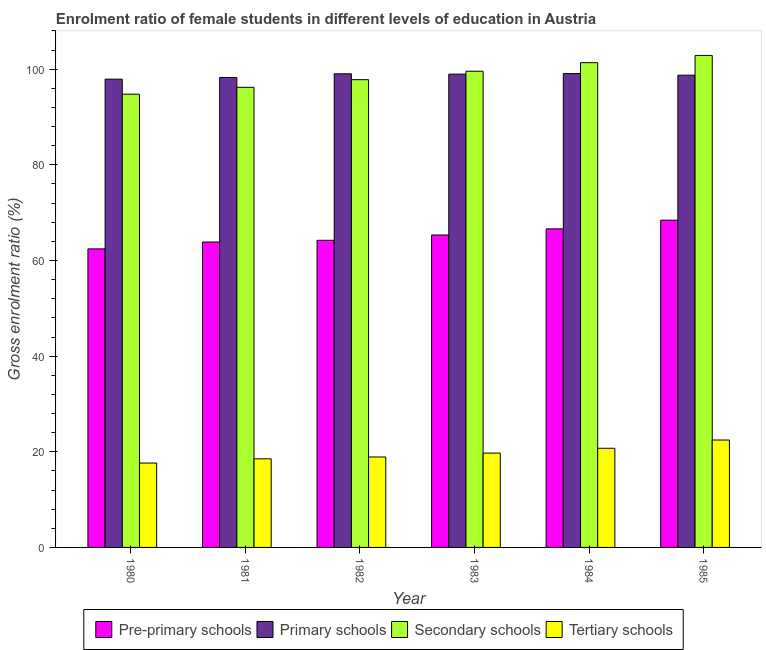How many different coloured bars are there?
Provide a short and direct response. 4. Are the number of bars on each tick of the X-axis equal?
Provide a succinct answer. Yes. How many bars are there on the 1st tick from the right?
Provide a short and direct response. 4. What is the label of the 6th group of bars from the left?
Keep it short and to the point. 1985. In how many cases, is the number of bars for a given year not equal to the number of legend labels?
Offer a very short reply. 0. What is the gross enrolment ratio(male) in tertiary schools in 1981?
Provide a short and direct response. 18.53. Across all years, what is the maximum gross enrolment ratio(male) in pre-primary schools?
Your answer should be compact. 68.43. Across all years, what is the minimum gross enrolment ratio(male) in tertiary schools?
Provide a succinct answer. 17.65. What is the total gross enrolment ratio(male) in pre-primary schools in the graph?
Your answer should be compact. 390.89. What is the difference between the gross enrolment ratio(male) in tertiary schools in 1982 and that in 1983?
Your answer should be compact. -0.82. What is the difference between the gross enrolment ratio(male) in secondary schools in 1983 and the gross enrolment ratio(male) in primary schools in 1984?
Your response must be concise. -1.79. What is the average gross enrolment ratio(male) in pre-primary schools per year?
Provide a short and direct response. 65.15. What is the ratio of the gross enrolment ratio(male) in tertiary schools in 1980 to that in 1985?
Offer a very short reply. 0.79. What is the difference between the highest and the second highest gross enrolment ratio(male) in primary schools?
Your answer should be very brief. 0.05. What is the difference between the highest and the lowest gross enrolment ratio(male) in tertiary schools?
Your answer should be very brief. 4.81. Is the sum of the gross enrolment ratio(male) in pre-primary schools in 1980 and 1985 greater than the maximum gross enrolment ratio(male) in secondary schools across all years?
Your response must be concise. Yes. Is it the case that in every year, the sum of the gross enrolment ratio(male) in tertiary schools and gross enrolment ratio(male) in secondary schools is greater than the sum of gross enrolment ratio(male) in pre-primary schools and gross enrolment ratio(male) in primary schools?
Offer a very short reply. No. What does the 3rd bar from the left in 1981 represents?
Keep it short and to the point. Secondary schools. What does the 2nd bar from the right in 1981 represents?
Your answer should be compact. Secondary schools. Is it the case that in every year, the sum of the gross enrolment ratio(male) in pre-primary schools and gross enrolment ratio(male) in primary schools is greater than the gross enrolment ratio(male) in secondary schools?
Keep it short and to the point. Yes. Are all the bars in the graph horizontal?
Provide a short and direct response. No. How many years are there in the graph?
Make the answer very short. 6. What is the difference between two consecutive major ticks on the Y-axis?
Keep it short and to the point. 20. Does the graph contain any zero values?
Ensure brevity in your answer.  No. Does the graph contain grids?
Keep it short and to the point. No. Where does the legend appear in the graph?
Your answer should be compact. Bottom center. How are the legend labels stacked?
Make the answer very short. Horizontal. What is the title of the graph?
Provide a short and direct response. Enrolment ratio of female students in different levels of education in Austria. What is the label or title of the X-axis?
Your response must be concise. Year. What is the Gross enrolment ratio (%) of Pre-primary schools in 1980?
Your answer should be very brief. 62.43. What is the Gross enrolment ratio (%) of Primary schools in 1980?
Make the answer very short. 97.92. What is the Gross enrolment ratio (%) in Secondary schools in 1980?
Keep it short and to the point. 94.78. What is the Gross enrolment ratio (%) of Tertiary schools in 1980?
Give a very brief answer. 17.65. What is the Gross enrolment ratio (%) in Pre-primary schools in 1981?
Offer a terse response. 63.86. What is the Gross enrolment ratio (%) in Primary schools in 1981?
Make the answer very short. 98.27. What is the Gross enrolment ratio (%) of Secondary schools in 1981?
Your response must be concise. 96.21. What is the Gross enrolment ratio (%) in Tertiary schools in 1981?
Your answer should be very brief. 18.53. What is the Gross enrolment ratio (%) in Pre-primary schools in 1982?
Your answer should be very brief. 64.22. What is the Gross enrolment ratio (%) of Primary schools in 1982?
Provide a short and direct response. 99.04. What is the Gross enrolment ratio (%) of Secondary schools in 1982?
Make the answer very short. 97.81. What is the Gross enrolment ratio (%) of Tertiary schools in 1982?
Your response must be concise. 18.91. What is the Gross enrolment ratio (%) in Pre-primary schools in 1983?
Ensure brevity in your answer.  65.33. What is the Gross enrolment ratio (%) of Primary schools in 1983?
Make the answer very short. 98.97. What is the Gross enrolment ratio (%) in Secondary schools in 1983?
Give a very brief answer. 99.58. What is the Gross enrolment ratio (%) in Tertiary schools in 1983?
Provide a short and direct response. 19.73. What is the Gross enrolment ratio (%) in Pre-primary schools in 1984?
Your response must be concise. 66.61. What is the Gross enrolment ratio (%) in Primary schools in 1984?
Make the answer very short. 99.09. What is the Gross enrolment ratio (%) in Secondary schools in 1984?
Provide a succinct answer. 101.37. What is the Gross enrolment ratio (%) in Tertiary schools in 1984?
Your answer should be very brief. 20.73. What is the Gross enrolment ratio (%) of Pre-primary schools in 1985?
Offer a terse response. 68.43. What is the Gross enrolment ratio (%) in Primary schools in 1985?
Keep it short and to the point. 98.75. What is the Gross enrolment ratio (%) of Secondary schools in 1985?
Provide a succinct answer. 102.88. What is the Gross enrolment ratio (%) in Tertiary schools in 1985?
Your answer should be very brief. 22.46. Across all years, what is the maximum Gross enrolment ratio (%) in Pre-primary schools?
Your response must be concise. 68.43. Across all years, what is the maximum Gross enrolment ratio (%) in Primary schools?
Provide a short and direct response. 99.09. Across all years, what is the maximum Gross enrolment ratio (%) of Secondary schools?
Keep it short and to the point. 102.88. Across all years, what is the maximum Gross enrolment ratio (%) in Tertiary schools?
Provide a short and direct response. 22.46. Across all years, what is the minimum Gross enrolment ratio (%) of Pre-primary schools?
Ensure brevity in your answer.  62.43. Across all years, what is the minimum Gross enrolment ratio (%) in Primary schools?
Provide a succinct answer. 97.92. Across all years, what is the minimum Gross enrolment ratio (%) in Secondary schools?
Offer a very short reply. 94.78. Across all years, what is the minimum Gross enrolment ratio (%) of Tertiary schools?
Offer a very short reply. 17.65. What is the total Gross enrolment ratio (%) in Pre-primary schools in the graph?
Give a very brief answer. 390.89. What is the total Gross enrolment ratio (%) in Primary schools in the graph?
Your answer should be very brief. 592.04. What is the total Gross enrolment ratio (%) of Secondary schools in the graph?
Offer a very short reply. 592.63. What is the total Gross enrolment ratio (%) in Tertiary schools in the graph?
Make the answer very short. 118. What is the difference between the Gross enrolment ratio (%) in Pre-primary schools in 1980 and that in 1981?
Your answer should be compact. -1.44. What is the difference between the Gross enrolment ratio (%) in Primary schools in 1980 and that in 1981?
Give a very brief answer. -0.35. What is the difference between the Gross enrolment ratio (%) of Secondary schools in 1980 and that in 1981?
Provide a succinct answer. -1.44. What is the difference between the Gross enrolment ratio (%) in Tertiary schools in 1980 and that in 1981?
Ensure brevity in your answer.  -0.88. What is the difference between the Gross enrolment ratio (%) of Pre-primary schools in 1980 and that in 1982?
Provide a short and direct response. -1.79. What is the difference between the Gross enrolment ratio (%) of Primary schools in 1980 and that in 1982?
Your answer should be compact. -1.12. What is the difference between the Gross enrolment ratio (%) in Secondary schools in 1980 and that in 1982?
Provide a succinct answer. -3.04. What is the difference between the Gross enrolment ratio (%) of Tertiary schools in 1980 and that in 1982?
Your answer should be very brief. -1.26. What is the difference between the Gross enrolment ratio (%) in Pre-primary schools in 1980 and that in 1983?
Provide a short and direct response. -2.9. What is the difference between the Gross enrolment ratio (%) in Primary schools in 1980 and that in 1983?
Ensure brevity in your answer.  -1.05. What is the difference between the Gross enrolment ratio (%) in Secondary schools in 1980 and that in 1983?
Give a very brief answer. -4.8. What is the difference between the Gross enrolment ratio (%) of Tertiary schools in 1980 and that in 1983?
Provide a short and direct response. -2.08. What is the difference between the Gross enrolment ratio (%) of Pre-primary schools in 1980 and that in 1984?
Your response must be concise. -4.19. What is the difference between the Gross enrolment ratio (%) of Primary schools in 1980 and that in 1984?
Your answer should be compact. -1.17. What is the difference between the Gross enrolment ratio (%) of Secondary schools in 1980 and that in 1984?
Your answer should be very brief. -6.59. What is the difference between the Gross enrolment ratio (%) of Tertiary schools in 1980 and that in 1984?
Your answer should be very brief. -3.09. What is the difference between the Gross enrolment ratio (%) of Pre-primary schools in 1980 and that in 1985?
Give a very brief answer. -6. What is the difference between the Gross enrolment ratio (%) in Primary schools in 1980 and that in 1985?
Your answer should be compact. -0.83. What is the difference between the Gross enrolment ratio (%) in Secondary schools in 1980 and that in 1985?
Your answer should be very brief. -8.11. What is the difference between the Gross enrolment ratio (%) in Tertiary schools in 1980 and that in 1985?
Your answer should be very brief. -4.81. What is the difference between the Gross enrolment ratio (%) in Pre-primary schools in 1981 and that in 1982?
Provide a succinct answer. -0.36. What is the difference between the Gross enrolment ratio (%) of Primary schools in 1981 and that in 1982?
Provide a short and direct response. -0.77. What is the difference between the Gross enrolment ratio (%) in Secondary schools in 1981 and that in 1982?
Your response must be concise. -1.6. What is the difference between the Gross enrolment ratio (%) of Tertiary schools in 1981 and that in 1982?
Provide a succinct answer. -0.38. What is the difference between the Gross enrolment ratio (%) of Pre-primary schools in 1981 and that in 1983?
Offer a terse response. -1.47. What is the difference between the Gross enrolment ratio (%) of Secondary schools in 1981 and that in 1983?
Ensure brevity in your answer.  -3.37. What is the difference between the Gross enrolment ratio (%) of Tertiary schools in 1981 and that in 1983?
Provide a succinct answer. -1.2. What is the difference between the Gross enrolment ratio (%) in Pre-primary schools in 1981 and that in 1984?
Offer a terse response. -2.75. What is the difference between the Gross enrolment ratio (%) in Primary schools in 1981 and that in 1984?
Ensure brevity in your answer.  -0.82. What is the difference between the Gross enrolment ratio (%) of Secondary schools in 1981 and that in 1984?
Make the answer very short. -5.15. What is the difference between the Gross enrolment ratio (%) of Tertiary schools in 1981 and that in 1984?
Give a very brief answer. -2.21. What is the difference between the Gross enrolment ratio (%) in Pre-primary schools in 1981 and that in 1985?
Give a very brief answer. -4.57. What is the difference between the Gross enrolment ratio (%) of Primary schools in 1981 and that in 1985?
Provide a succinct answer. -0.48. What is the difference between the Gross enrolment ratio (%) of Secondary schools in 1981 and that in 1985?
Make the answer very short. -6.67. What is the difference between the Gross enrolment ratio (%) of Tertiary schools in 1981 and that in 1985?
Offer a terse response. -3.93. What is the difference between the Gross enrolment ratio (%) of Pre-primary schools in 1982 and that in 1983?
Offer a terse response. -1.11. What is the difference between the Gross enrolment ratio (%) of Primary schools in 1982 and that in 1983?
Offer a terse response. 0.07. What is the difference between the Gross enrolment ratio (%) in Secondary schools in 1982 and that in 1983?
Give a very brief answer. -1.76. What is the difference between the Gross enrolment ratio (%) of Tertiary schools in 1982 and that in 1983?
Provide a short and direct response. -0.82. What is the difference between the Gross enrolment ratio (%) of Pre-primary schools in 1982 and that in 1984?
Your response must be concise. -2.39. What is the difference between the Gross enrolment ratio (%) of Primary schools in 1982 and that in 1984?
Your answer should be compact. -0.05. What is the difference between the Gross enrolment ratio (%) in Secondary schools in 1982 and that in 1984?
Give a very brief answer. -3.55. What is the difference between the Gross enrolment ratio (%) of Tertiary schools in 1982 and that in 1984?
Make the answer very short. -1.82. What is the difference between the Gross enrolment ratio (%) in Pre-primary schools in 1982 and that in 1985?
Offer a terse response. -4.21. What is the difference between the Gross enrolment ratio (%) of Primary schools in 1982 and that in 1985?
Offer a very short reply. 0.3. What is the difference between the Gross enrolment ratio (%) of Secondary schools in 1982 and that in 1985?
Ensure brevity in your answer.  -5.07. What is the difference between the Gross enrolment ratio (%) in Tertiary schools in 1982 and that in 1985?
Provide a short and direct response. -3.55. What is the difference between the Gross enrolment ratio (%) of Pre-primary schools in 1983 and that in 1984?
Provide a short and direct response. -1.28. What is the difference between the Gross enrolment ratio (%) of Primary schools in 1983 and that in 1984?
Ensure brevity in your answer.  -0.12. What is the difference between the Gross enrolment ratio (%) in Secondary schools in 1983 and that in 1984?
Provide a short and direct response. -1.79. What is the difference between the Gross enrolment ratio (%) in Tertiary schools in 1983 and that in 1984?
Provide a succinct answer. -1.01. What is the difference between the Gross enrolment ratio (%) in Pre-primary schools in 1983 and that in 1985?
Your answer should be compact. -3.1. What is the difference between the Gross enrolment ratio (%) in Primary schools in 1983 and that in 1985?
Ensure brevity in your answer.  0.22. What is the difference between the Gross enrolment ratio (%) in Secondary schools in 1983 and that in 1985?
Offer a very short reply. -3.3. What is the difference between the Gross enrolment ratio (%) of Tertiary schools in 1983 and that in 1985?
Offer a very short reply. -2.73. What is the difference between the Gross enrolment ratio (%) in Pre-primary schools in 1984 and that in 1985?
Your response must be concise. -1.82. What is the difference between the Gross enrolment ratio (%) in Primary schools in 1984 and that in 1985?
Your answer should be compact. 0.34. What is the difference between the Gross enrolment ratio (%) in Secondary schools in 1984 and that in 1985?
Your answer should be very brief. -1.52. What is the difference between the Gross enrolment ratio (%) of Tertiary schools in 1984 and that in 1985?
Offer a terse response. -1.72. What is the difference between the Gross enrolment ratio (%) of Pre-primary schools in 1980 and the Gross enrolment ratio (%) of Primary schools in 1981?
Provide a succinct answer. -35.84. What is the difference between the Gross enrolment ratio (%) in Pre-primary schools in 1980 and the Gross enrolment ratio (%) in Secondary schools in 1981?
Ensure brevity in your answer.  -33.78. What is the difference between the Gross enrolment ratio (%) in Pre-primary schools in 1980 and the Gross enrolment ratio (%) in Tertiary schools in 1981?
Make the answer very short. 43.9. What is the difference between the Gross enrolment ratio (%) of Primary schools in 1980 and the Gross enrolment ratio (%) of Secondary schools in 1981?
Provide a succinct answer. 1.71. What is the difference between the Gross enrolment ratio (%) of Primary schools in 1980 and the Gross enrolment ratio (%) of Tertiary schools in 1981?
Ensure brevity in your answer.  79.4. What is the difference between the Gross enrolment ratio (%) of Secondary schools in 1980 and the Gross enrolment ratio (%) of Tertiary schools in 1981?
Give a very brief answer. 76.25. What is the difference between the Gross enrolment ratio (%) of Pre-primary schools in 1980 and the Gross enrolment ratio (%) of Primary schools in 1982?
Your response must be concise. -36.61. What is the difference between the Gross enrolment ratio (%) in Pre-primary schools in 1980 and the Gross enrolment ratio (%) in Secondary schools in 1982?
Your answer should be compact. -35.39. What is the difference between the Gross enrolment ratio (%) in Pre-primary schools in 1980 and the Gross enrolment ratio (%) in Tertiary schools in 1982?
Offer a terse response. 43.52. What is the difference between the Gross enrolment ratio (%) in Primary schools in 1980 and the Gross enrolment ratio (%) in Secondary schools in 1982?
Ensure brevity in your answer.  0.11. What is the difference between the Gross enrolment ratio (%) of Primary schools in 1980 and the Gross enrolment ratio (%) of Tertiary schools in 1982?
Your answer should be compact. 79.01. What is the difference between the Gross enrolment ratio (%) of Secondary schools in 1980 and the Gross enrolment ratio (%) of Tertiary schools in 1982?
Make the answer very short. 75.87. What is the difference between the Gross enrolment ratio (%) of Pre-primary schools in 1980 and the Gross enrolment ratio (%) of Primary schools in 1983?
Offer a very short reply. -36.54. What is the difference between the Gross enrolment ratio (%) in Pre-primary schools in 1980 and the Gross enrolment ratio (%) in Secondary schools in 1983?
Provide a succinct answer. -37.15. What is the difference between the Gross enrolment ratio (%) of Pre-primary schools in 1980 and the Gross enrolment ratio (%) of Tertiary schools in 1983?
Offer a terse response. 42.7. What is the difference between the Gross enrolment ratio (%) of Primary schools in 1980 and the Gross enrolment ratio (%) of Secondary schools in 1983?
Your answer should be very brief. -1.66. What is the difference between the Gross enrolment ratio (%) of Primary schools in 1980 and the Gross enrolment ratio (%) of Tertiary schools in 1983?
Your answer should be compact. 78.19. What is the difference between the Gross enrolment ratio (%) in Secondary schools in 1980 and the Gross enrolment ratio (%) in Tertiary schools in 1983?
Ensure brevity in your answer.  75.05. What is the difference between the Gross enrolment ratio (%) in Pre-primary schools in 1980 and the Gross enrolment ratio (%) in Primary schools in 1984?
Ensure brevity in your answer.  -36.66. What is the difference between the Gross enrolment ratio (%) of Pre-primary schools in 1980 and the Gross enrolment ratio (%) of Secondary schools in 1984?
Give a very brief answer. -38.94. What is the difference between the Gross enrolment ratio (%) of Pre-primary schools in 1980 and the Gross enrolment ratio (%) of Tertiary schools in 1984?
Provide a short and direct response. 41.69. What is the difference between the Gross enrolment ratio (%) in Primary schools in 1980 and the Gross enrolment ratio (%) in Secondary schools in 1984?
Provide a short and direct response. -3.45. What is the difference between the Gross enrolment ratio (%) in Primary schools in 1980 and the Gross enrolment ratio (%) in Tertiary schools in 1984?
Offer a terse response. 77.19. What is the difference between the Gross enrolment ratio (%) in Secondary schools in 1980 and the Gross enrolment ratio (%) in Tertiary schools in 1984?
Provide a succinct answer. 74.04. What is the difference between the Gross enrolment ratio (%) of Pre-primary schools in 1980 and the Gross enrolment ratio (%) of Primary schools in 1985?
Offer a very short reply. -36.32. What is the difference between the Gross enrolment ratio (%) in Pre-primary schools in 1980 and the Gross enrolment ratio (%) in Secondary schools in 1985?
Keep it short and to the point. -40.45. What is the difference between the Gross enrolment ratio (%) in Pre-primary schools in 1980 and the Gross enrolment ratio (%) in Tertiary schools in 1985?
Ensure brevity in your answer.  39.97. What is the difference between the Gross enrolment ratio (%) in Primary schools in 1980 and the Gross enrolment ratio (%) in Secondary schools in 1985?
Offer a terse response. -4.96. What is the difference between the Gross enrolment ratio (%) in Primary schools in 1980 and the Gross enrolment ratio (%) in Tertiary schools in 1985?
Your answer should be very brief. 75.46. What is the difference between the Gross enrolment ratio (%) in Secondary schools in 1980 and the Gross enrolment ratio (%) in Tertiary schools in 1985?
Your response must be concise. 72.32. What is the difference between the Gross enrolment ratio (%) of Pre-primary schools in 1981 and the Gross enrolment ratio (%) of Primary schools in 1982?
Your answer should be compact. -35.18. What is the difference between the Gross enrolment ratio (%) in Pre-primary schools in 1981 and the Gross enrolment ratio (%) in Secondary schools in 1982?
Make the answer very short. -33.95. What is the difference between the Gross enrolment ratio (%) of Pre-primary schools in 1981 and the Gross enrolment ratio (%) of Tertiary schools in 1982?
Provide a succinct answer. 44.95. What is the difference between the Gross enrolment ratio (%) in Primary schools in 1981 and the Gross enrolment ratio (%) in Secondary schools in 1982?
Provide a short and direct response. 0.46. What is the difference between the Gross enrolment ratio (%) in Primary schools in 1981 and the Gross enrolment ratio (%) in Tertiary schools in 1982?
Your response must be concise. 79.36. What is the difference between the Gross enrolment ratio (%) of Secondary schools in 1981 and the Gross enrolment ratio (%) of Tertiary schools in 1982?
Your answer should be very brief. 77.3. What is the difference between the Gross enrolment ratio (%) of Pre-primary schools in 1981 and the Gross enrolment ratio (%) of Primary schools in 1983?
Give a very brief answer. -35.11. What is the difference between the Gross enrolment ratio (%) in Pre-primary schools in 1981 and the Gross enrolment ratio (%) in Secondary schools in 1983?
Offer a terse response. -35.71. What is the difference between the Gross enrolment ratio (%) in Pre-primary schools in 1981 and the Gross enrolment ratio (%) in Tertiary schools in 1983?
Keep it short and to the point. 44.14. What is the difference between the Gross enrolment ratio (%) of Primary schools in 1981 and the Gross enrolment ratio (%) of Secondary schools in 1983?
Provide a succinct answer. -1.31. What is the difference between the Gross enrolment ratio (%) of Primary schools in 1981 and the Gross enrolment ratio (%) of Tertiary schools in 1983?
Ensure brevity in your answer.  78.54. What is the difference between the Gross enrolment ratio (%) of Secondary schools in 1981 and the Gross enrolment ratio (%) of Tertiary schools in 1983?
Make the answer very short. 76.49. What is the difference between the Gross enrolment ratio (%) of Pre-primary schools in 1981 and the Gross enrolment ratio (%) of Primary schools in 1984?
Ensure brevity in your answer.  -35.22. What is the difference between the Gross enrolment ratio (%) in Pre-primary schools in 1981 and the Gross enrolment ratio (%) in Secondary schools in 1984?
Your response must be concise. -37.5. What is the difference between the Gross enrolment ratio (%) in Pre-primary schools in 1981 and the Gross enrolment ratio (%) in Tertiary schools in 1984?
Make the answer very short. 43.13. What is the difference between the Gross enrolment ratio (%) of Primary schools in 1981 and the Gross enrolment ratio (%) of Secondary schools in 1984?
Offer a very short reply. -3.1. What is the difference between the Gross enrolment ratio (%) in Primary schools in 1981 and the Gross enrolment ratio (%) in Tertiary schools in 1984?
Make the answer very short. 77.54. What is the difference between the Gross enrolment ratio (%) in Secondary schools in 1981 and the Gross enrolment ratio (%) in Tertiary schools in 1984?
Provide a short and direct response. 75.48. What is the difference between the Gross enrolment ratio (%) of Pre-primary schools in 1981 and the Gross enrolment ratio (%) of Primary schools in 1985?
Make the answer very short. -34.88. What is the difference between the Gross enrolment ratio (%) of Pre-primary schools in 1981 and the Gross enrolment ratio (%) of Secondary schools in 1985?
Offer a very short reply. -39.02. What is the difference between the Gross enrolment ratio (%) in Pre-primary schools in 1981 and the Gross enrolment ratio (%) in Tertiary schools in 1985?
Your response must be concise. 41.41. What is the difference between the Gross enrolment ratio (%) of Primary schools in 1981 and the Gross enrolment ratio (%) of Secondary schools in 1985?
Your answer should be compact. -4.61. What is the difference between the Gross enrolment ratio (%) of Primary schools in 1981 and the Gross enrolment ratio (%) of Tertiary schools in 1985?
Your response must be concise. 75.81. What is the difference between the Gross enrolment ratio (%) of Secondary schools in 1981 and the Gross enrolment ratio (%) of Tertiary schools in 1985?
Your answer should be very brief. 73.76. What is the difference between the Gross enrolment ratio (%) in Pre-primary schools in 1982 and the Gross enrolment ratio (%) in Primary schools in 1983?
Offer a very short reply. -34.75. What is the difference between the Gross enrolment ratio (%) in Pre-primary schools in 1982 and the Gross enrolment ratio (%) in Secondary schools in 1983?
Provide a succinct answer. -35.36. What is the difference between the Gross enrolment ratio (%) of Pre-primary schools in 1982 and the Gross enrolment ratio (%) of Tertiary schools in 1983?
Your response must be concise. 44.5. What is the difference between the Gross enrolment ratio (%) in Primary schools in 1982 and the Gross enrolment ratio (%) in Secondary schools in 1983?
Your response must be concise. -0.54. What is the difference between the Gross enrolment ratio (%) in Primary schools in 1982 and the Gross enrolment ratio (%) in Tertiary schools in 1983?
Your answer should be compact. 79.32. What is the difference between the Gross enrolment ratio (%) in Secondary schools in 1982 and the Gross enrolment ratio (%) in Tertiary schools in 1983?
Ensure brevity in your answer.  78.09. What is the difference between the Gross enrolment ratio (%) of Pre-primary schools in 1982 and the Gross enrolment ratio (%) of Primary schools in 1984?
Make the answer very short. -34.86. What is the difference between the Gross enrolment ratio (%) of Pre-primary schools in 1982 and the Gross enrolment ratio (%) of Secondary schools in 1984?
Your answer should be compact. -37.14. What is the difference between the Gross enrolment ratio (%) of Pre-primary schools in 1982 and the Gross enrolment ratio (%) of Tertiary schools in 1984?
Your answer should be very brief. 43.49. What is the difference between the Gross enrolment ratio (%) in Primary schools in 1982 and the Gross enrolment ratio (%) in Secondary schools in 1984?
Your answer should be compact. -2.32. What is the difference between the Gross enrolment ratio (%) of Primary schools in 1982 and the Gross enrolment ratio (%) of Tertiary schools in 1984?
Provide a short and direct response. 78.31. What is the difference between the Gross enrolment ratio (%) of Secondary schools in 1982 and the Gross enrolment ratio (%) of Tertiary schools in 1984?
Your answer should be very brief. 77.08. What is the difference between the Gross enrolment ratio (%) in Pre-primary schools in 1982 and the Gross enrolment ratio (%) in Primary schools in 1985?
Offer a terse response. -34.52. What is the difference between the Gross enrolment ratio (%) of Pre-primary schools in 1982 and the Gross enrolment ratio (%) of Secondary schools in 1985?
Ensure brevity in your answer.  -38.66. What is the difference between the Gross enrolment ratio (%) in Pre-primary schools in 1982 and the Gross enrolment ratio (%) in Tertiary schools in 1985?
Ensure brevity in your answer.  41.77. What is the difference between the Gross enrolment ratio (%) of Primary schools in 1982 and the Gross enrolment ratio (%) of Secondary schools in 1985?
Your answer should be compact. -3.84. What is the difference between the Gross enrolment ratio (%) of Primary schools in 1982 and the Gross enrolment ratio (%) of Tertiary schools in 1985?
Your response must be concise. 76.58. What is the difference between the Gross enrolment ratio (%) of Secondary schools in 1982 and the Gross enrolment ratio (%) of Tertiary schools in 1985?
Offer a very short reply. 75.36. What is the difference between the Gross enrolment ratio (%) of Pre-primary schools in 1983 and the Gross enrolment ratio (%) of Primary schools in 1984?
Ensure brevity in your answer.  -33.76. What is the difference between the Gross enrolment ratio (%) in Pre-primary schools in 1983 and the Gross enrolment ratio (%) in Secondary schools in 1984?
Keep it short and to the point. -36.04. What is the difference between the Gross enrolment ratio (%) in Pre-primary schools in 1983 and the Gross enrolment ratio (%) in Tertiary schools in 1984?
Offer a terse response. 44.6. What is the difference between the Gross enrolment ratio (%) in Primary schools in 1983 and the Gross enrolment ratio (%) in Secondary schools in 1984?
Provide a succinct answer. -2.4. What is the difference between the Gross enrolment ratio (%) in Primary schools in 1983 and the Gross enrolment ratio (%) in Tertiary schools in 1984?
Offer a very short reply. 78.24. What is the difference between the Gross enrolment ratio (%) of Secondary schools in 1983 and the Gross enrolment ratio (%) of Tertiary schools in 1984?
Ensure brevity in your answer.  78.85. What is the difference between the Gross enrolment ratio (%) of Pre-primary schools in 1983 and the Gross enrolment ratio (%) of Primary schools in 1985?
Provide a short and direct response. -33.42. What is the difference between the Gross enrolment ratio (%) in Pre-primary schools in 1983 and the Gross enrolment ratio (%) in Secondary schools in 1985?
Provide a succinct answer. -37.55. What is the difference between the Gross enrolment ratio (%) of Pre-primary schools in 1983 and the Gross enrolment ratio (%) of Tertiary schools in 1985?
Your response must be concise. 42.87. What is the difference between the Gross enrolment ratio (%) in Primary schools in 1983 and the Gross enrolment ratio (%) in Secondary schools in 1985?
Your response must be concise. -3.91. What is the difference between the Gross enrolment ratio (%) in Primary schools in 1983 and the Gross enrolment ratio (%) in Tertiary schools in 1985?
Give a very brief answer. 76.51. What is the difference between the Gross enrolment ratio (%) in Secondary schools in 1983 and the Gross enrolment ratio (%) in Tertiary schools in 1985?
Offer a very short reply. 77.12. What is the difference between the Gross enrolment ratio (%) of Pre-primary schools in 1984 and the Gross enrolment ratio (%) of Primary schools in 1985?
Your answer should be very brief. -32.13. What is the difference between the Gross enrolment ratio (%) of Pre-primary schools in 1984 and the Gross enrolment ratio (%) of Secondary schools in 1985?
Offer a very short reply. -36.27. What is the difference between the Gross enrolment ratio (%) of Pre-primary schools in 1984 and the Gross enrolment ratio (%) of Tertiary schools in 1985?
Provide a succinct answer. 44.16. What is the difference between the Gross enrolment ratio (%) in Primary schools in 1984 and the Gross enrolment ratio (%) in Secondary schools in 1985?
Give a very brief answer. -3.79. What is the difference between the Gross enrolment ratio (%) in Primary schools in 1984 and the Gross enrolment ratio (%) in Tertiary schools in 1985?
Your answer should be very brief. 76.63. What is the difference between the Gross enrolment ratio (%) of Secondary schools in 1984 and the Gross enrolment ratio (%) of Tertiary schools in 1985?
Provide a succinct answer. 78.91. What is the average Gross enrolment ratio (%) of Pre-primary schools per year?
Make the answer very short. 65.15. What is the average Gross enrolment ratio (%) of Primary schools per year?
Keep it short and to the point. 98.67. What is the average Gross enrolment ratio (%) in Secondary schools per year?
Give a very brief answer. 98.77. What is the average Gross enrolment ratio (%) of Tertiary schools per year?
Your answer should be compact. 19.67. In the year 1980, what is the difference between the Gross enrolment ratio (%) in Pre-primary schools and Gross enrolment ratio (%) in Primary schools?
Offer a very short reply. -35.49. In the year 1980, what is the difference between the Gross enrolment ratio (%) of Pre-primary schools and Gross enrolment ratio (%) of Secondary schools?
Offer a terse response. -32.35. In the year 1980, what is the difference between the Gross enrolment ratio (%) of Pre-primary schools and Gross enrolment ratio (%) of Tertiary schools?
Your response must be concise. 44.78. In the year 1980, what is the difference between the Gross enrolment ratio (%) of Primary schools and Gross enrolment ratio (%) of Secondary schools?
Offer a terse response. 3.14. In the year 1980, what is the difference between the Gross enrolment ratio (%) in Primary schools and Gross enrolment ratio (%) in Tertiary schools?
Keep it short and to the point. 80.28. In the year 1980, what is the difference between the Gross enrolment ratio (%) in Secondary schools and Gross enrolment ratio (%) in Tertiary schools?
Offer a terse response. 77.13. In the year 1981, what is the difference between the Gross enrolment ratio (%) in Pre-primary schools and Gross enrolment ratio (%) in Primary schools?
Provide a short and direct response. -34.41. In the year 1981, what is the difference between the Gross enrolment ratio (%) in Pre-primary schools and Gross enrolment ratio (%) in Secondary schools?
Offer a very short reply. -32.35. In the year 1981, what is the difference between the Gross enrolment ratio (%) of Pre-primary schools and Gross enrolment ratio (%) of Tertiary schools?
Provide a short and direct response. 45.34. In the year 1981, what is the difference between the Gross enrolment ratio (%) in Primary schools and Gross enrolment ratio (%) in Secondary schools?
Your response must be concise. 2.06. In the year 1981, what is the difference between the Gross enrolment ratio (%) of Primary schools and Gross enrolment ratio (%) of Tertiary schools?
Ensure brevity in your answer.  79.75. In the year 1981, what is the difference between the Gross enrolment ratio (%) of Secondary schools and Gross enrolment ratio (%) of Tertiary schools?
Offer a very short reply. 77.69. In the year 1982, what is the difference between the Gross enrolment ratio (%) of Pre-primary schools and Gross enrolment ratio (%) of Primary schools?
Your answer should be compact. -34.82. In the year 1982, what is the difference between the Gross enrolment ratio (%) in Pre-primary schools and Gross enrolment ratio (%) in Secondary schools?
Give a very brief answer. -33.59. In the year 1982, what is the difference between the Gross enrolment ratio (%) of Pre-primary schools and Gross enrolment ratio (%) of Tertiary schools?
Offer a very short reply. 45.31. In the year 1982, what is the difference between the Gross enrolment ratio (%) in Primary schools and Gross enrolment ratio (%) in Secondary schools?
Make the answer very short. 1.23. In the year 1982, what is the difference between the Gross enrolment ratio (%) in Primary schools and Gross enrolment ratio (%) in Tertiary schools?
Ensure brevity in your answer.  80.13. In the year 1982, what is the difference between the Gross enrolment ratio (%) in Secondary schools and Gross enrolment ratio (%) in Tertiary schools?
Make the answer very short. 78.9. In the year 1983, what is the difference between the Gross enrolment ratio (%) in Pre-primary schools and Gross enrolment ratio (%) in Primary schools?
Keep it short and to the point. -33.64. In the year 1983, what is the difference between the Gross enrolment ratio (%) in Pre-primary schools and Gross enrolment ratio (%) in Secondary schools?
Provide a succinct answer. -34.25. In the year 1983, what is the difference between the Gross enrolment ratio (%) of Pre-primary schools and Gross enrolment ratio (%) of Tertiary schools?
Your answer should be very brief. 45.6. In the year 1983, what is the difference between the Gross enrolment ratio (%) of Primary schools and Gross enrolment ratio (%) of Secondary schools?
Keep it short and to the point. -0.61. In the year 1983, what is the difference between the Gross enrolment ratio (%) of Primary schools and Gross enrolment ratio (%) of Tertiary schools?
Keep it short and to the point. 79.24. In the year 1983, what is the difference between the Gross enrolment ratio (%) of Secondary schools and Gross enrolment ratio (%) of Tertiary schools?
Offer a very short reply. 79.85. In the year 1984, what is the difference between the Gross enrolment ratio (%) in Pre-primary schools and Gross enrolment ratio (%) in Primary schools?
Your answer should be very brief. -32.47. In the year 1984, what is the difference between the Gross enrolment ratio (%) of Pre-primary schools and Gross enrolment ratio (%) of Secondary schools?
Give a very brief answer. -34.75. In the year 1984, what is the difference between the Gross enrolment ratio (%) in Pre-primary schools and Gross enrolment ratio (%) in Tertiary schools?
Ensure brevity in your answer.  45.88. In the year 1984, what is the difference between the Gross enrolment ratio (%) in Primary schools and Gross enrolment ratio (%) in Secondary schools?
Provide a short and direct response. -2.28. In the year 1984, what is the difference between the Gross enrolment ratio (%) of Primary schools and Gross enrolment ratio (%) of Tertiary schools?
Your response must be concise. 78.35. In the year 1984, what is the difference between the Gross enrolment ratio (%) in Secondary schools and Gross enrolment ratio (%) in Tertiary schools?
Offer a very short reply. 80.63. In the year 1985, what is the difference between the Gross enrolment ratio (%) in Pre-primary schools and Gross enrolment ratio (%) in Primary schools?
Offer a terse response. -30.32. In the year 1985, what is the difference between the Gross enrolment ratio (%) in Pre-primary schools and Gross enrolment ratio (%) in Secondary schools?
Your answer should be compact. -34.45. In the year 1985, what is the difference between the Gross enrolment ratio (%) in Pre-primary schools and Gross enrolment ratio (%) in Tertiary schools?
Provide a succinct answer. 45.97. In the year 1985, what is the difference between the Gross enrolment ratio (%) of Primary schools and Gross enrolment ratio (%) of Secondary schools?
Offer a terse response. -4.14. In the year 1985, what is the difference between the Gross enrolment ratio (%) in Primary schools and Gross enrolment ratio (%) in Tertiary schools?
Give a very brief answer. 76.29. In the year 1985, what is the difference between the Gross enrolment ratio (%) of Secondary schools and Gross enrolment ratio (%) of Tertiary schools?
Make the answer very short. 80.42. What is the ratio of the Gross enrolment ratio (%) in Pre-primary schools in 1980 to that in 1981?
Provide a succinct answer. 0.98. What is the ratio of the Gross enrolment ratio (%) in Secondary schools in 1980 to that in 1981?
Provide a short and direct response. 0.99. What is the ratio of the Gross enrolment ratio (%) in Tertiary schools in 1980 to that in 1981?
Offer a very short reply. 0.95. What is the ratio of the Gross enrolment ratio (%) in Pre-primary schools in 1980 to that in 1982?
Offer a very short reply. 0.97. What is the ratio of the Gross enrolment ratio (%) in Primary schools in 1980 to that in 1982?
Your answer should be very brief. 0.99. What is the ratio of the Gross enrolment ratio (%) in Secondary schools in 1980 to that in 1982?
Ensure brevity in your answer.  0.97. What is the ratio of the Gross enrolment ratio (%) in Tertiary schools in 1980 to that in 1982?
Offer a very short reply. 0.93. What is the ratio of the Gross enrolment ratio (%) in Pre-primary schools in 1980 to that in 1983?
Provide a short and direct response. 0.96. What is the ratio of the Gross enrolment ratio (%) of Primary schools in 1980 to that in 1983?
Offer a terse response. 0.99. What is the ratio of the Gross enrolment ratio (%) of Secondary schools in 1980 to that in 1983?
Ensure brevity in your answer.  0.95. What is the ratio of the Gross enrolment ratio (%) of Tertiary schools in 1980 to that in 1983?
Your answer should be very brief. 0.89. What is the ratio of the Gross enrolment ratio (%) of Pre-primary schools in 1980 to that in 1984?
Your answer should be very brief. 0.94. What is the ratio of the Gross enrolment ratio (%) of Secondary schools in 1980 to that in 1984?
Ensure brevity in your answer.  0.94. What is the ratio of the Gross enrolment ratio (%) in Tertiary schools in 1980 to that in 1984?
Make the answer very short. 0.85. What is the ratio of the Gross enrolment ratio (%) in Pre-primary schools in 1980 to that in 1985?
Offer a terse response. 0.91. What is the ratio of the Gross enrolment ratio (%) in Primary schools in 1980 to that in 1985?
Your answer should be very brief. 0.99. What is the ratio of the Gross enrolment ratio (%) of Secondary schools in 1980 to that in 1985?
Your response must be concise. 0.92. What is the ratio of the Gross enrolment ratio (%) of Tertiary schools in 1980 to that in 1985?
Offer a terse response. 0.79. What is the ratio of the Gross enrolment ratio (%) in Primary schools in 1981 to that in 1982?
Your answer should be very brief. 0.99. What is the ratio of the Gross enrolment ratio (%) of Secondary schools in 1981 to that in 1982?
Offer a very short reply. 0.98. What is the ratio of the Gross enrolment ratio (%) of Tertiary schools in 1981 to that in 1982?
Your answer should be compact. 0.98. What is the ratio of the Gross enrolment ratio (%) in Pre-primary schools in 1981 to that in 1983?
Your response must be concise. 0.98. What is the ratio of the Gross enrolment ratio (%) of Primary schools in 1981 to that in 1983?
Your response must be concise. 0.99. What is the ratio of the Gross enrolment ratio (%) of Secondary schools in 1981 to that in 1983?
Offer a terse response. 0.97. What is the ratio of the Gross enrolment ratio (%) of Tertiary schools in 1981 to that in 1983?
Give a very brief answer. 0.94. What is the ratio of the Gross enrolment ratio (%) of Pre-primary schools in 1981 to that in 1984?
Your response must be concise. 0.96. What is the ratio of the Gross enrolment ratio (%) of Secondary schools in 1981 to that in 1984?
Offer a very short reply. 0.95. What is the ratio of the Gross enrolment ratio (%) in Tertiary schools in 1981 to that in 1984?
Provide a short and direct response. 0.89. What is the ratio of the Gross enrolment ratio (%) of Pre-primary schools in 1981 to that in 1985?
Your response must be concise. 0.93. What is the ratio of the Gross enrolment ratio (%) in Secondary schools in 1981 to that in 1985?
Ensure brevity in your answer.  0.94. What is the ratio of the Gross enrolment ratio (%) of Tertiary schools in 1981 to that in 1985?
Provide a short and direct response. 0.82. What is the ratio of the Gross enrolment ratio (%) in Secondary schools in 1982 to that in 1983?
Offer a very short reply. 0.98. What is the ratio of the Gross enrolment ratio (%) of Tertiary schools in 1982 to that in 1983?
Provide a short and direct response. 0.96. What is the ratio of the Gross enrolment ratio (%) of Pre-primary schools in 1982 to that in 1984?
Provide a short and direct response. 0.96. What is the ratio of the Gross enrolment ratio (%) in Primary schools in 1982 to that in 1984?
Offer a terse response. 1. What is the ratio of the Gross enrolment ratio (%) in Tertiary schools in 1982 to that in 1984?
Your answer should be compact. 0.91. What is the ratio of the Gross enrolment ratio (%) of Pre-primary schools in 1982 to that in 1985?
Your answer should be compact. 0.94. What is the ratio of the Gross enrolment ratio (%) in Secondary schools in 1982 to that in 1985?
Keep it short and to the point. 0.95. What is the ratio of the Gross enrolment ratio (%) in Tertiary schools in 1982 to that in 1985?
Offer a terse response. 0.84. What is the ratio of the Gross enrolment ratio (%) of Pre-primary schools in 1983 to that in 1984?
Your answer should be very brief. 0.98. What is the ratio of the Gross enrolment ratio (%) in Secondary schools in 1983 to that in 1984?
Keep it short and to the point. 0.98. What is the ratio of the Gross enrolment ratio (%) in Tertiary schools in 1983 to that in 1984?
Give a very brief answer. 0.95. What is the ratio of the Gross enrolment ratio (%) in Pre-primary schools in 1983 to that in 1985?
Your response must be concise. 0.95. What is the ratio of the Gross enrolment ratio (%) in Secondary schools in 1983 to that in 1985?
Provide a succinct answer. 0.97. What is the ratio of the Gross enrolment ratio (%) of Tertiary schools in 1983 to that in 1985?
Provide a succinct answer. 0.88. What is the ratio of the Gross enrolment ratio (%) of Pre-primary schools in 1984 to that in 1985?
Offer a very short reply. 0.97. What is the ratio of the Gross enrolment ratio (%) of Secondary schools in 1984 to that in 1985?
Provide a succinct answer. 0.99. What is the ratio of the Gross enrolment ratio (%) in Tertiary schools in 1984 to that in 1985?
Your answer should be compact. 0.92. What is the difference between the highest and the second highest Gross enrolment ratio (%) of Pre-primary schools?
Ensure brevity in your answer.  1.82. What is the difference between the highest and the second highest Gross enrolment ratio (%) in Primary schools?
Provide a succinct answer. 0.05. What is the difference between the highest and the second highest Gross enrolment ratio (%) in Secondary schools?
Offer a very short reply. 1.52. What is the difference between the highest and the second highest Gross enrolment ratio (%) in Tertiary schools?
Make the answer very short. 1.72. What is the difference between the highest and the lowest Gross enrolment ratio (%) in Pre-primary schools?
Give a very brief answer. 6. What is the difference between the highest and the lowest Gross enrolment ratio (%) in Primary schools?
Your answer should be very brief. 1.17. What is the difference between the highest and the lowest Gross enrolment ratio (%) in Secondary schools?
Keep it short and to the point. 8.11. What is the difference between the highest and the lowest Gross enrolment ratio (%) in Tertiary schools?
Your answer should be very brief. 4.81. 